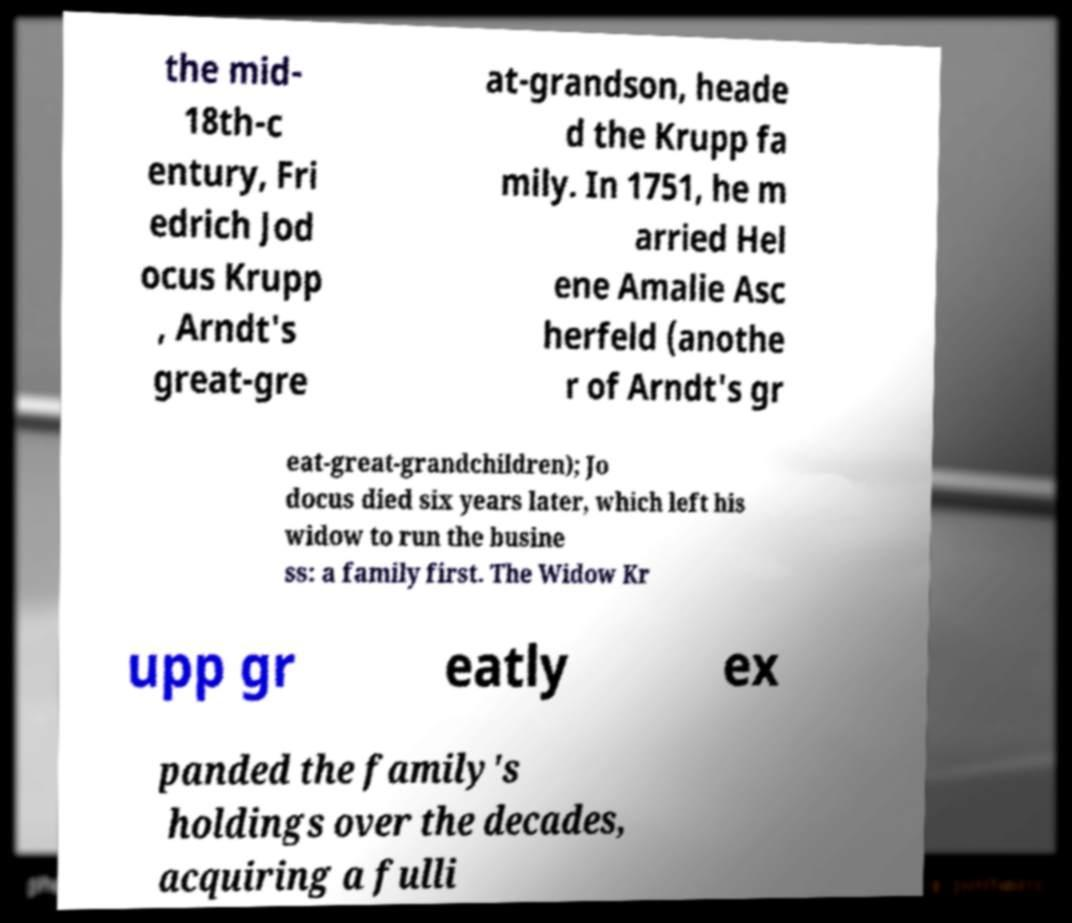For documentation purposes, I need the text within this image transcribed. Could you provide that? the mid- 18th-c entury, Fri edrich Jod ocus Krupp , Arndt's great-gre at-grandson, heade d the Krupp fa mily. In 1751, he m arried Hel ene Amalie Asc herfeld (anothe r of Arndt's gr eat-great-grandchildren); Jo docus died six years later, which left his widow to run the busine ss: a family first. The Widow Kr upp gr eatly ex panded the family's holdings over the decades, acquiring a fulli 